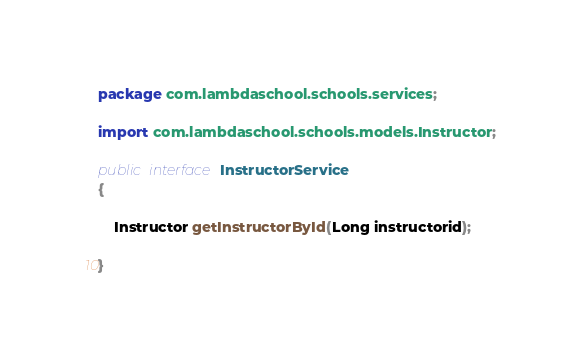<code> <loc_0><loc_0><loc_500><loc_500><_Java_>package com.lambdaschool.schools.services;

import com.lambdaschool.schools.models.Instructor;

public interface InstructorService
{

    Instructor getInstructorById(Long instructorid);

}
</code> 